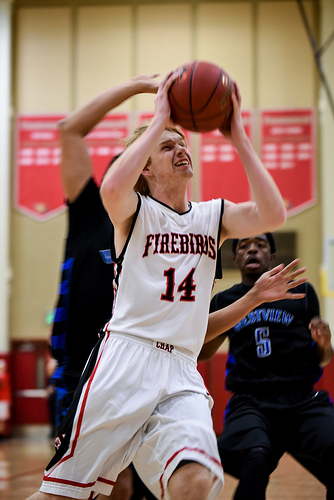<image>
Is there a ball on the boy? No. The ball is not positioned on the boy. They may be near each other, but the ball is not supported by or resting on top of the boy. Where is the ball in relation to the jersey? Is it behind the jersey? No. The ball is not behind the jersey. From this viewpoint, the ball appears to be positioned elsewhere in the scene. Is there a ball to the right of the boy? No. The ball is not to the right of the boy. The horizontal positioning shows a different relationship. 